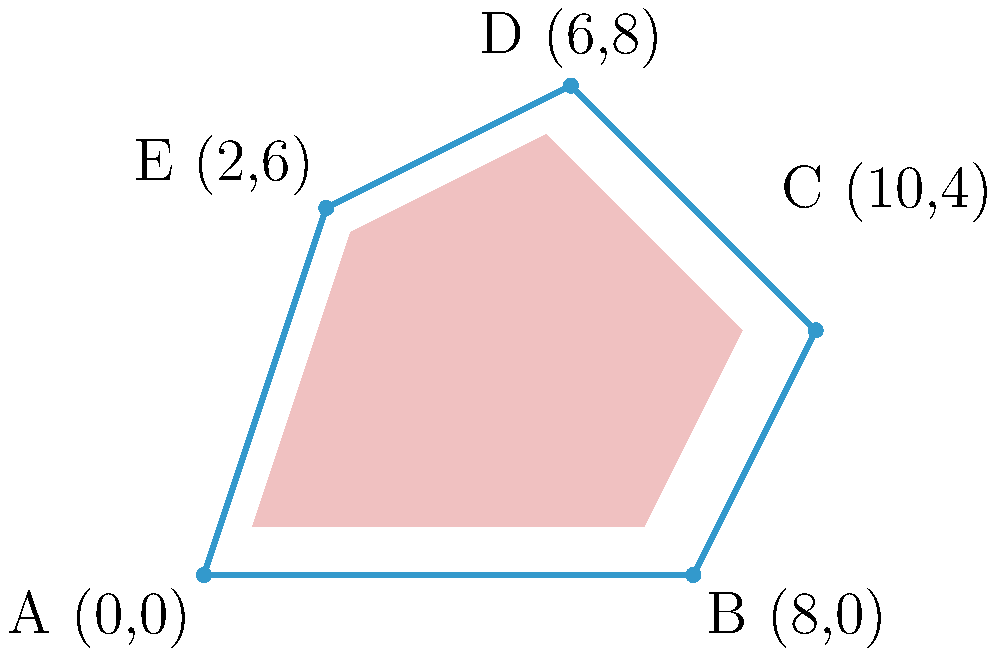As part of an investigation into the transparency of art exhibition spaces, you're analyzing an irregularly shaped gallery room. The room's shape is represented by the coordinates: A(0,0), B(8,0), C(10,4), D(6,8), and E(2,6). Calculate the area of this exhibition space using coordinate geometry. How might the size and shape of such spaces impact the visibility and accessibility of artworks? To calculate the area of this irregular polygon, we can use the Shoelace formula (also known as the surveyor's formula). This method is particularly useful for calculating the area of irregular shapes in coordinate geometry.

The Shoelace formula is given by:

$$Area = \frac{1}{2}|(x_1y_2 + x_2y_3 + ... + x_ny_1) - (y_1x_2 + y_2x_3 + ... + y_nx_1)|$$

Where $(x_i, y_i)$ are the coordinates of each vertex.

Let's apply this formula to our polygon:

1) First, let's list our coordinates in order:
   A(0,0), B(8,0), C(10,4), D(6,8), E(2,6)

2) Now, let's calculate the first part of the formula:
   $$(0 \cdot 0) + (8 \cdot 4) + (10 \cdot 8) + (6 \cdot 6) + (2 \cdot 0) = 0 + 32 + 80 + 36 + 0 = 148$$

3) Next, let's calculate the second part:
   $$(0 \cdot 8) + (0 \cdot 10) + (4 \cdot 6) + (8 \cdot 2) + (6 \cdot 0) = 0 + 0 + 24 + 16 + 0 = 40$$

4) Now, we subtract the second part from the first:
   $$148 - 40 = 108$$

5) Finally, we divide by 2:
   $$\frac{108}{2} = 54$$

Therefore, the area of the exhibition space is 54 square units.

This irregular shape could impact the visibility and accessibility of artworks by creating unconventional viewing angles and potentially limiting the space for larger pieces. The varying distances between walls might also affect lighting conditions and crowd flow, which are crucial factors in art exhibition design and transparency.
Answer: 54 square units 